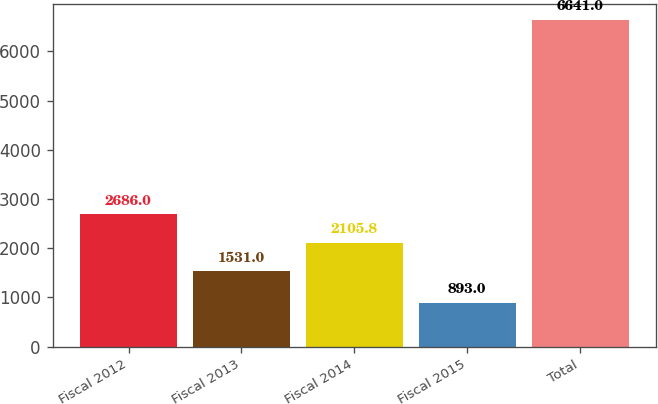<chart> <loc_0><loc_0><loc_500><loc_500><bar_chart><fcel>Fiscal 2012<fcel>Fiscal 2013<fcel>Fiscal 2014<fcel>Fiscal 2015<fcel>Total<nl><fcel>2686<fcel>1531<fcel>2105.8<fcel>893<fcel>6641<nl></chart> 